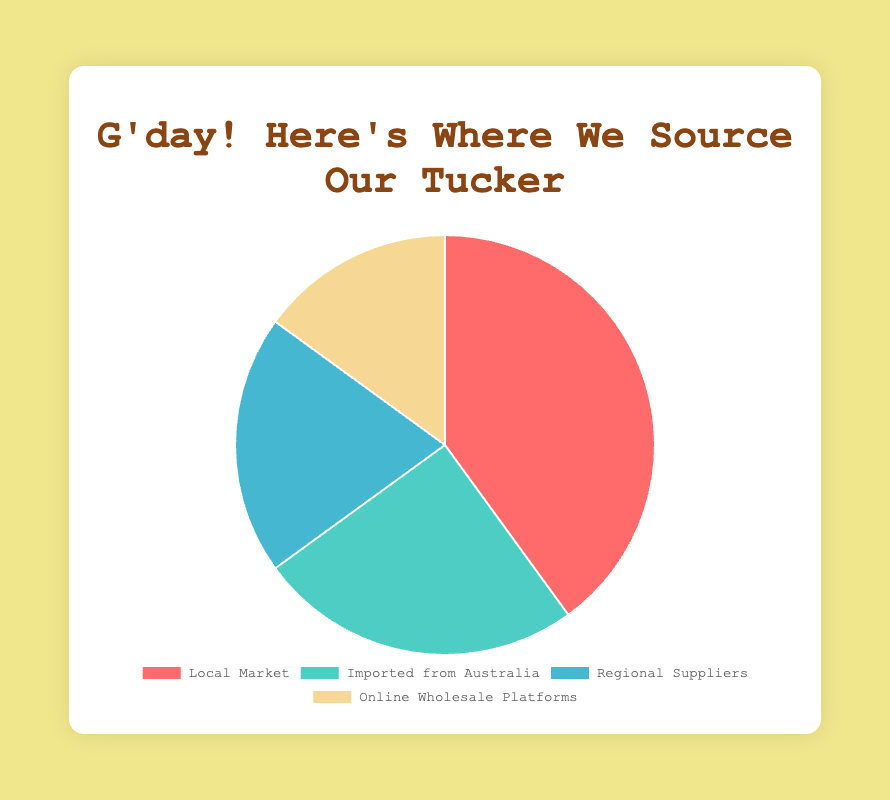What percentage of ingredients comes from Local Market and Regional Suppliers combined? The percentage from Local Market is 40% and from Regional Suppliers is 20%. Adding them gives 40% + 20% = 60%.
Answer: 60% Which source provides the least percentage of ingredients? The sources are Local Market (40%), Imported from Australia (25%), Regional Suppliers (20%), and Online Wholesale Platforms (15%). The least percentage comes from Online Wholesale Platforms at 15%.
Answer: Online Wholesale Platforms What color represents the ingredients imported from Australia? The data shows that ingredients from Australia make up 25%, and the color associated with this slice is teal.
Answer: Teal Is the percentage of ingredients from Local Market greater than the percentage from Online Wholesale Platforms? Yes. Local Market contributes 40% while Online Wholesale Platforms contribute 15%. Thus, 40% is greater than 15%.
Answer: Yes Which source of ingredients has a percentage closest to one-fourth of the total sources? One-fourth is 25%. The sources are Local Market (40%), Imported from Australia (25%), Regional Suppliers (20%), and Online Wholesale Platforms (15%). The closest is "Imported from Australia" at 25%.
Answer: Imported from Australia What is the difference in percentage between Local Market and Regional Suppliers? Local Market contributes 40%, and Regional Suppliers contribute 20%. The difference is 40% - 20% = 20%.
Answer: 20% If the percentages were to be sorted in descending order, which source would be the second-highest? The sources in descending order are Local Market (40%), Imported from Australia (25%), Regional Suppliers (20%), and Online Wholesale Platforms (15%). The second-highest is "Imported from Australia" at 25%.
Answer: Imported from Australia What is the total percentage contribution of all non-local sources (i.e., Imported from Australia, Regional Suppliers, Online Wholesale Platforms)? Imported from Australia is 25%, Regional Suppliers is 20%, and Online Wholesale Platforms is 15%. Adding these gives 25% + 20% + 15% = 60%.
Answer: 60% What is the average percentage of all the sources? There are four sources with percentages of 40%, 25%, 20%, and 15%. The sum is 40% + 25% + 20% + 15% = 100%. The average is 100% / 4 = 25%.
Answer: 25% Which source shares the same visual attribute of a bright yellow color? The data points that make up the chart have distinct colors. The one associated with the bright yellow color represents the Online Wholesale Platforms.
Answer: Online Wholesale Platforms 